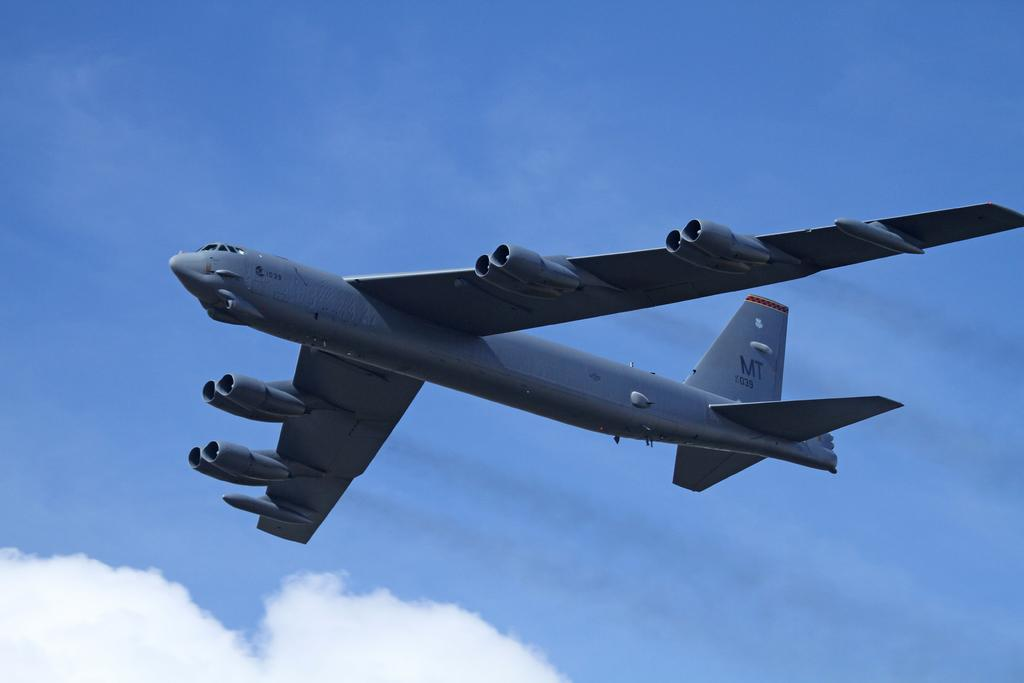What color is the airplane in the image? The airplane in the image is gray. What is the airplane doing in the image? The airplane is flying in the air. What can be seen in the background of the image? There are clouds in the background of the image. What is the color of the sky in the image? The sky is blue in the image. Can you tell me how the girl is swimming in the image? There is no girl present in the image, and therefore no swimming activity can be observed. 